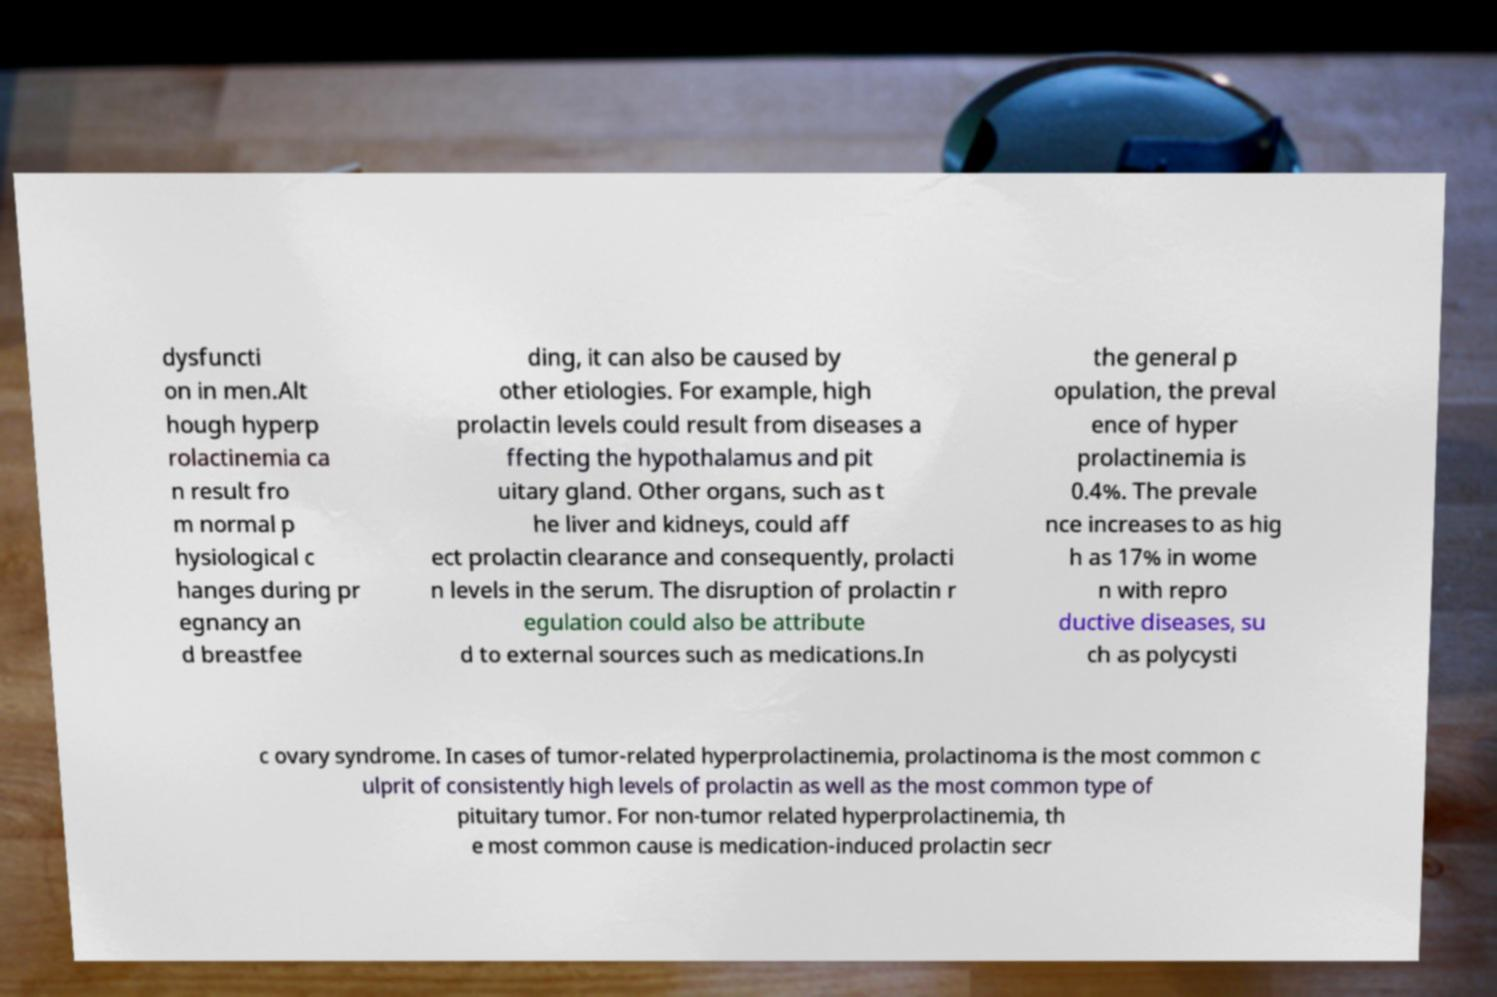Please identify and transcribe the text found in this image. dysfuncti on in men.Alt hough hyperp rolactinemia ca n result fro m normal p hysiological c hanges during pr egnancy an d breastfee ding, it can also be caused by other etiologies. For example, high prolactin levels could result from diseases a ffecting the hypothalamus and pit uitary gland. Other organs, such as t he liver and kidneys, could aff ect prolactin clearance and consequently, prolacti n levels in the serum. The disruption of prolactin r egulation could also be attribute d to external sources such as medications.In the general p opulation, the preval ence of hyper prolactinemia is 0.4%. The prevale nce increases to as hig h as 17% in wome n with repro ductive diseases, su ch as polycysti c ovary syndrome. In cases of tumor-related hyperprolactinemia, prolactinoma is the most common c ulprit of consistently high levels of prolactin as well as the most common type of pituitary tumor. For non-tumor related hyperprolactinemia, th e most common cause is medication-induced prolactin secr 